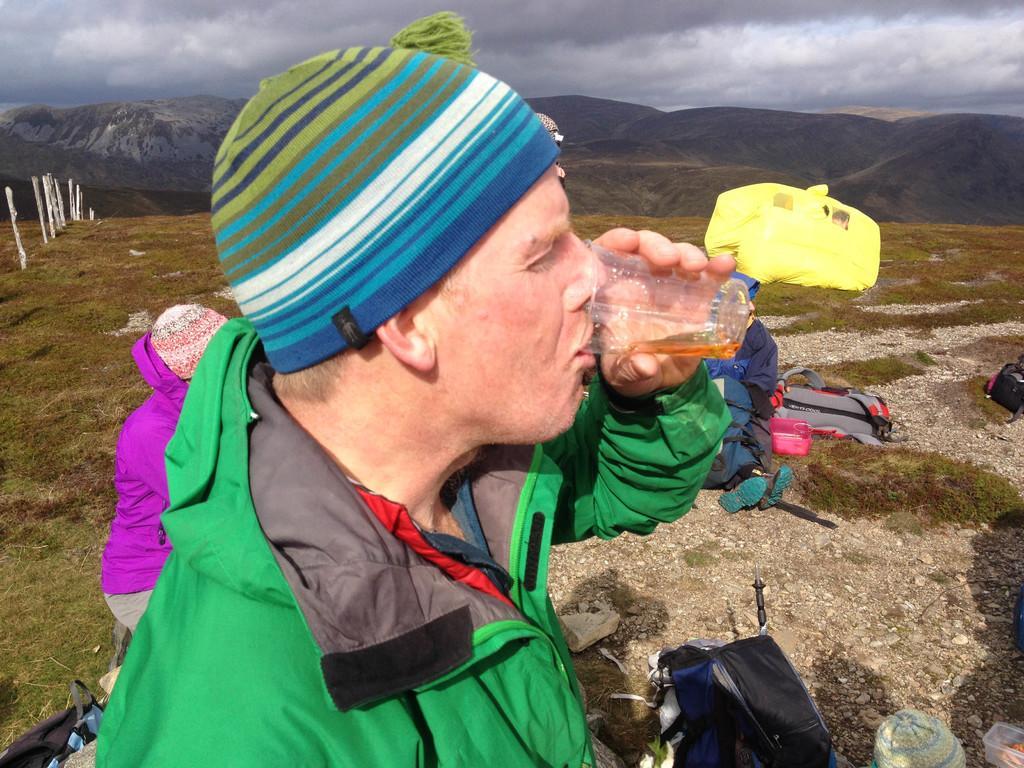Could you give a brief overview of what you see in this image? In this picture I can see there is a man standing and drinking, there are a few people sitting on the floor. There is grass on the floor and there are mountains in the backdrop and the sky is clear. 